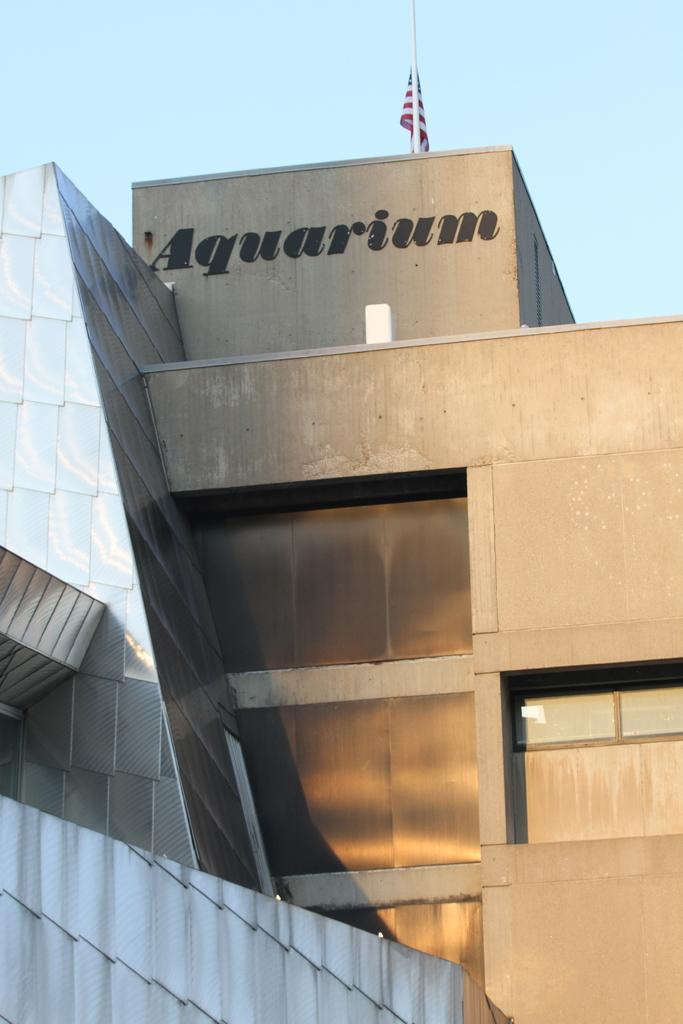<image>
Offer a succinct explanation of the picture presented. A large building with the word, Aquarium, written on the outside of it. 